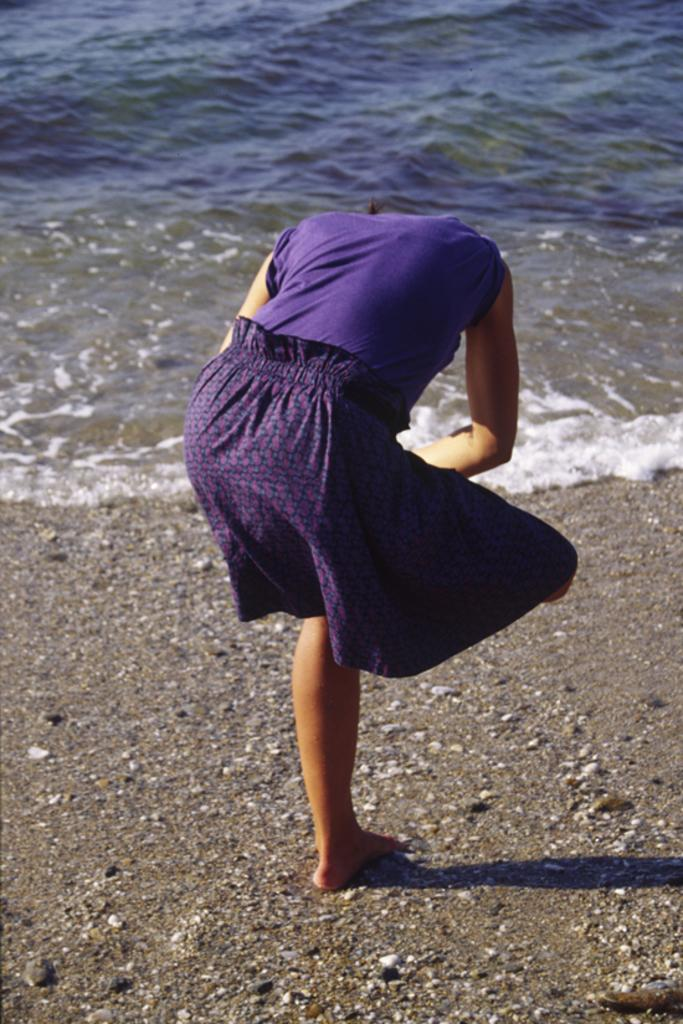Who is present in the image? There is a woman in the image. Where is the woman located in relation to the water? The woman is standing on the land side of the water. What type of roof can be seen on the woman in the image? There is no roof present in the image, as it features a woman standing on the land side of the water. 